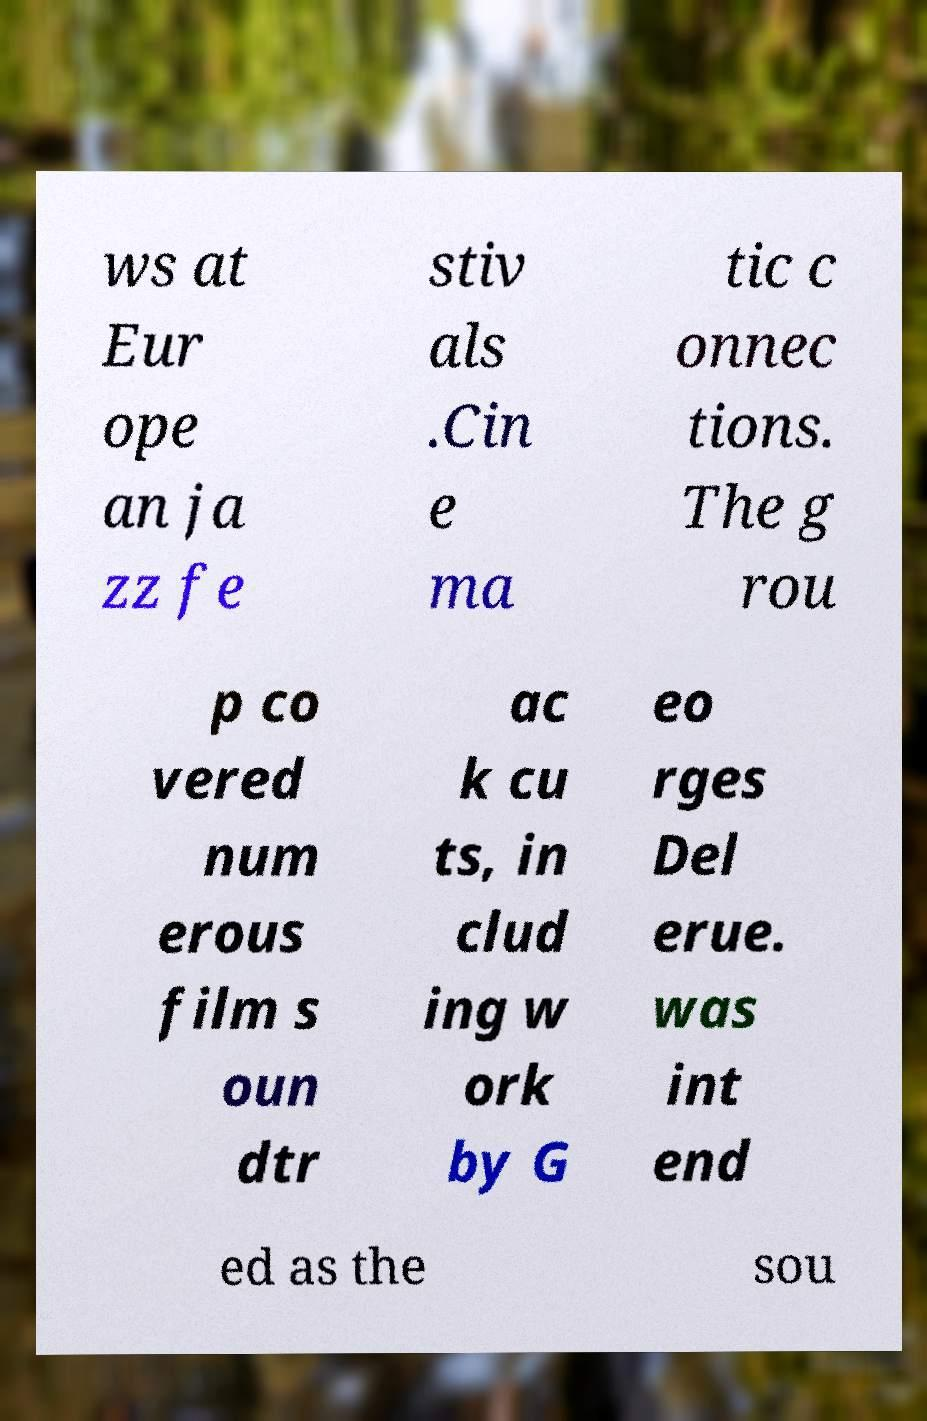Could you extract and type out the text from this image? ws at Eur ope an ja zz fe stiv als .Cin e ma tic c onnec tions. The g rou p co vered num erous film s oun dtr ac k cu ts, in clud ing w ork by G eo rges Del erue. was int end ed as the sou 